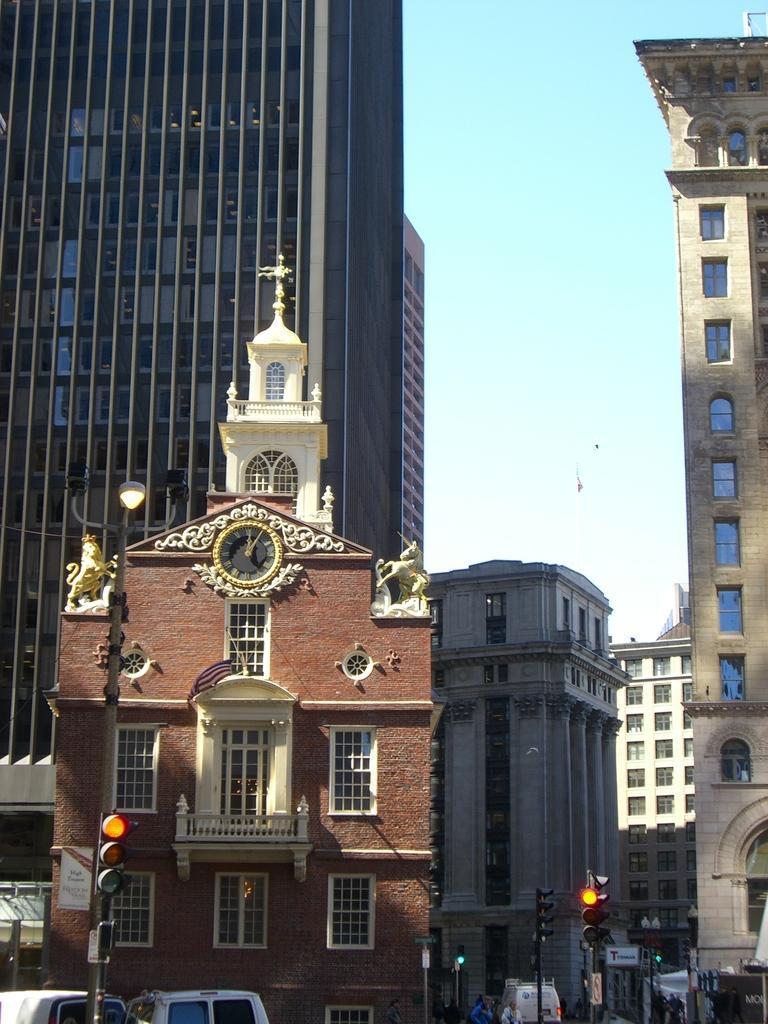Please provide a concise description of this image. In this picture, there are buildings which are in different colors and sizes. At the bottom, there are signal lights, vehicles, people etc. At the top, there is a sky. 